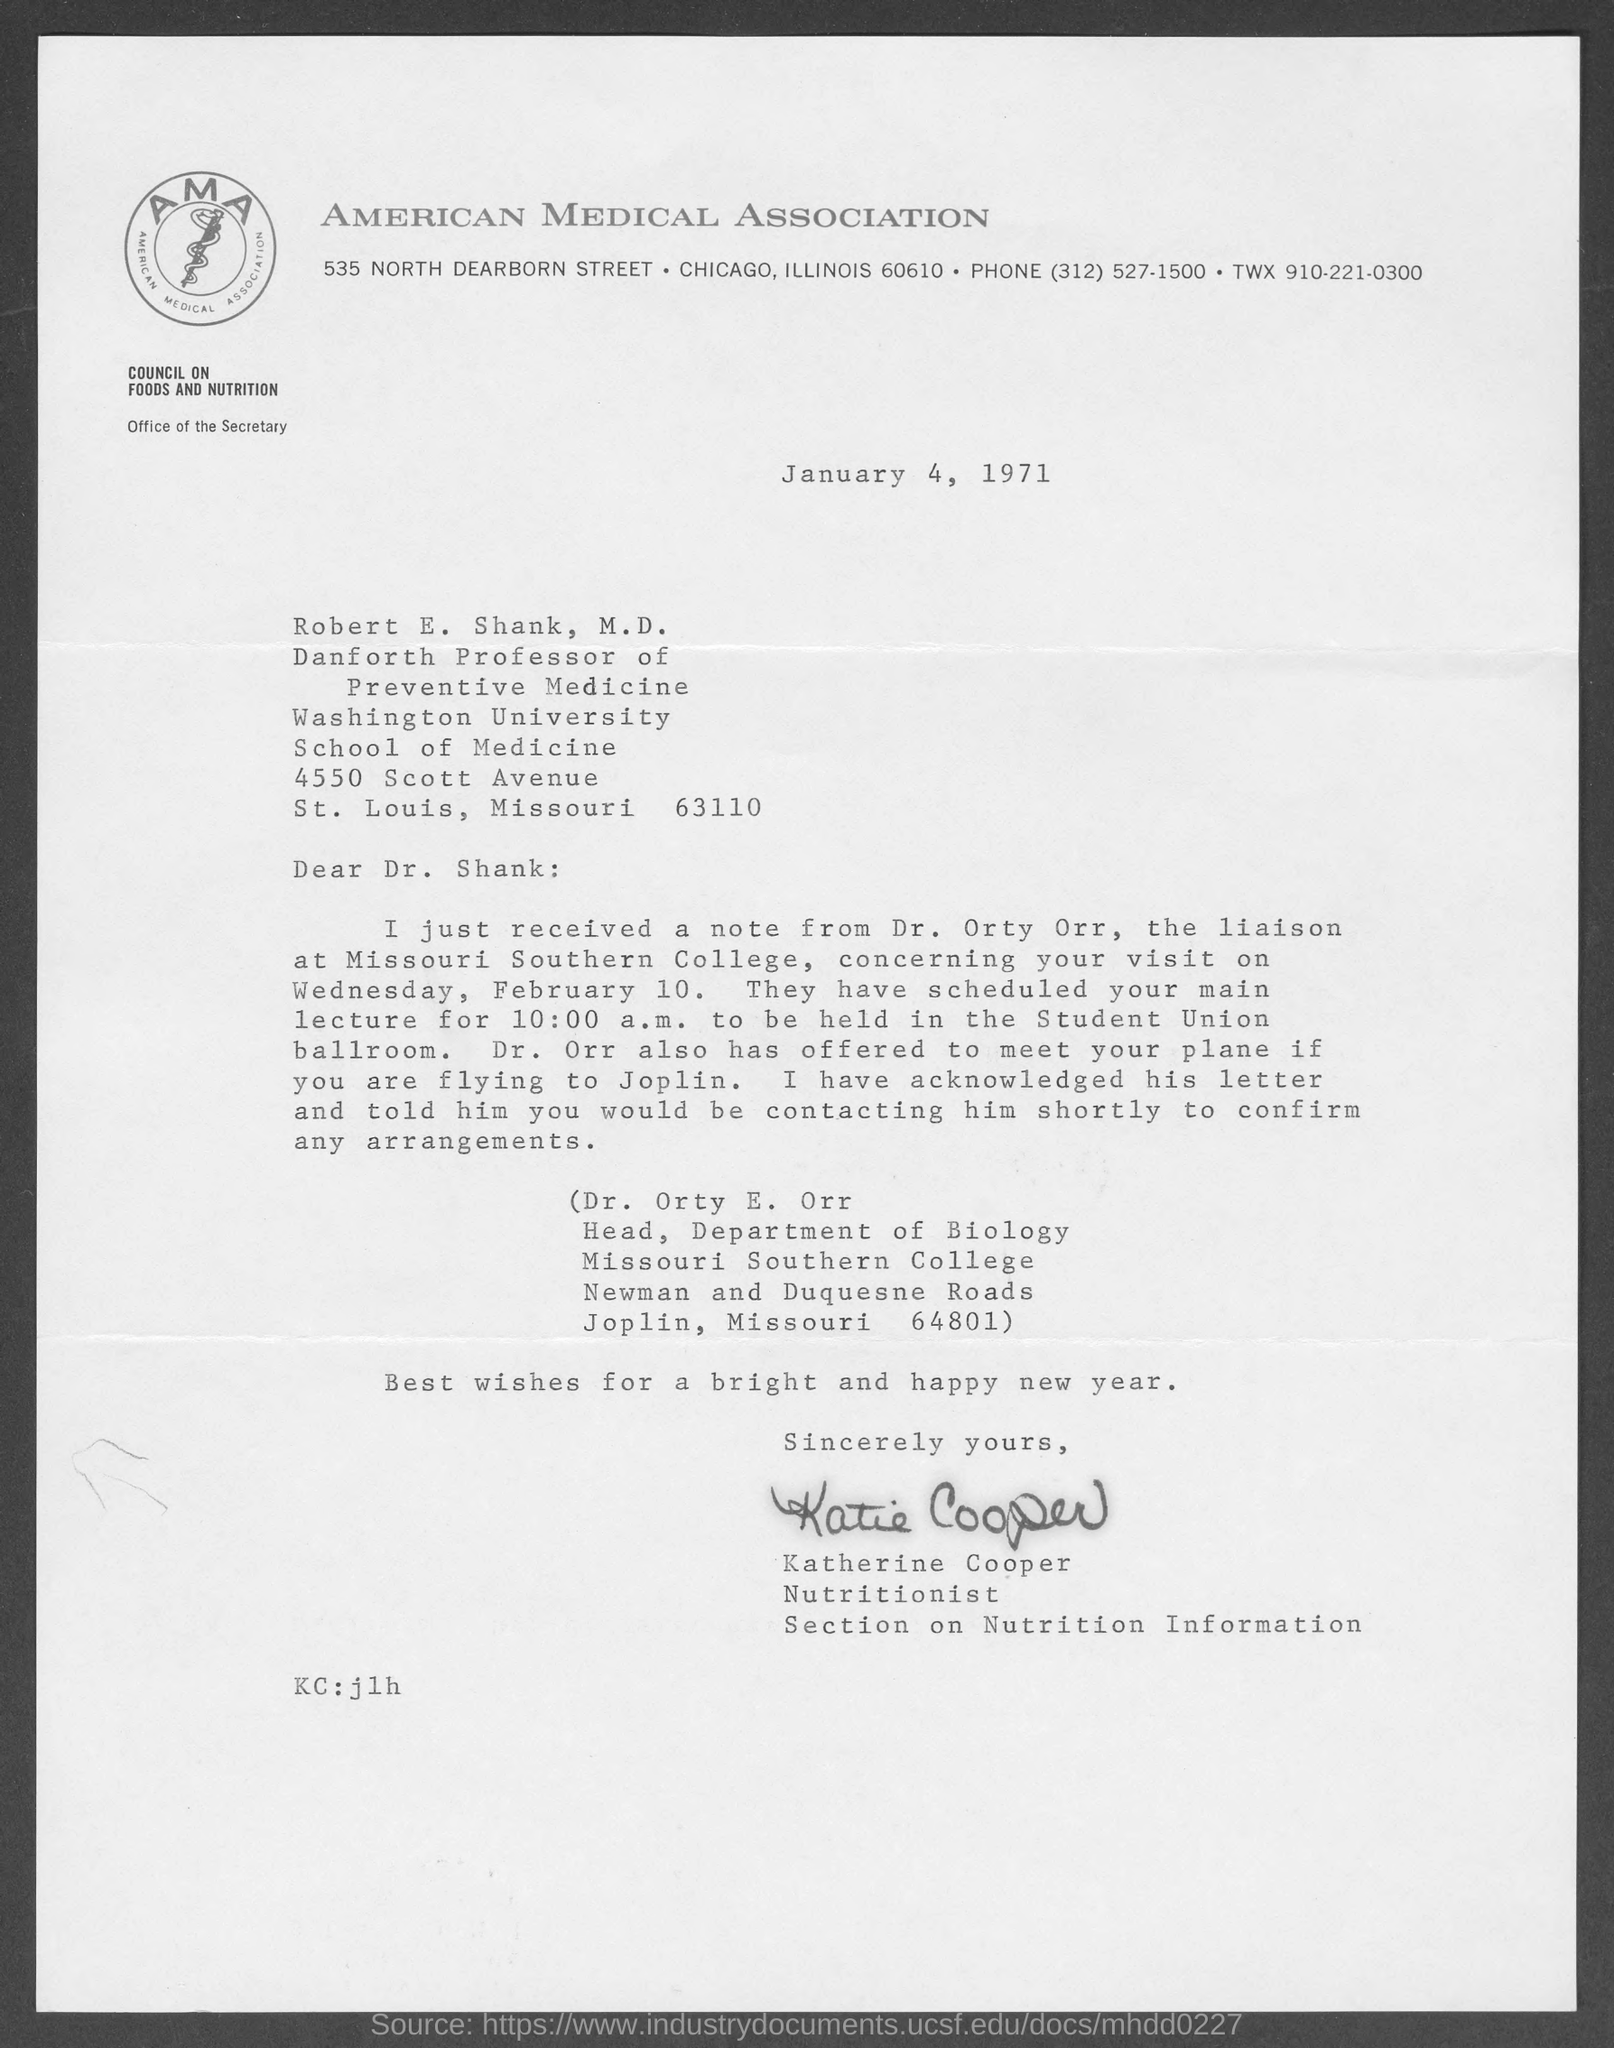List a handful of essential elements in this visual. The American Medical Association is located in Chicago, Illinois. The letter was written by Katherine Cooper. The date mentioned is January 4, 1971. 